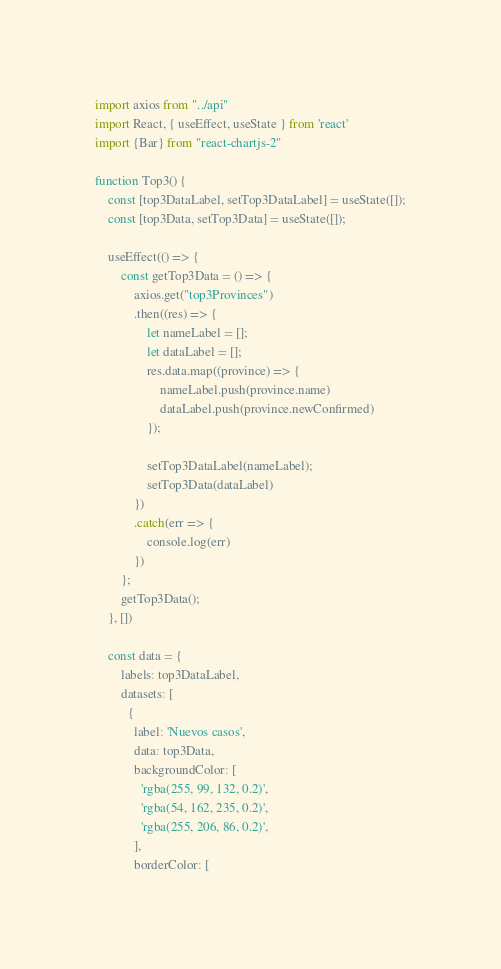<code> <loc_0><loc_0><loc_500><loc_500><_JavaScript_>import axios from "../api"
import React, { useEffect, useState } from 'react'
import {Bar} from "react-chartjs-2"

function Top3() {
    const [top3DataLabel, setTop3DataLabel] = useState([]);
    const [top3Data, setTop3Data] = useState([]);

    useEffect(() => {
        const getTop3Data = () => {
            axios.get("top3Provinces")
            .then((res) => {
                let nameLabel = [];
                let dataLabel = []; 
                res.data.map((province) => {
                    nameLabel.push(province.name)
                    dataLabel.push(province.newConfirmed)
                });
                
                setTop3DataLabel(nameLabel);
                setTop3Data(dataLabel)
            })
            .catch(err => {
                console.log(err)
            })
        };
        getTop3Data();
    }, [])

    const data = {
        labels: top3DataLabel,
        datasets: [
          {
            label: 'Nuevos casos',
            data: top3Data,
            backgroundColor: [
              'rgba(255, 99, 132, 0.2)',
              'rgba(54, 162, 235, 0.2)',
              'rgba(255, 206, 86, 0.2)',
            ],
            borderColor: [</code> 